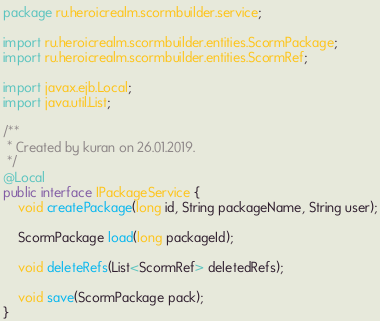Convert code to text. <code><loc_0><loc_0><loc_500><loc_500><_Java_>package ru.heroicrealm.scormbuilder.service;

import ru.heroicrealm.scormbuilder.entities.ScormPackage;
import ru.heroicrealm.scormbuilder.entities.ScormRef;

import javax.ejb.Local;
import java.util.List;

/**
 * Created by kuran on 26.01.2019.
 */
@Local
public interface IPackageService {
    void createPackage(long id, String packageName, String user);

    ScormPackage load(long packageId);

    void deleteRefs(List<ScormRef> deletedRefs);

    void save(ScormPackage pack);
}
</code> 